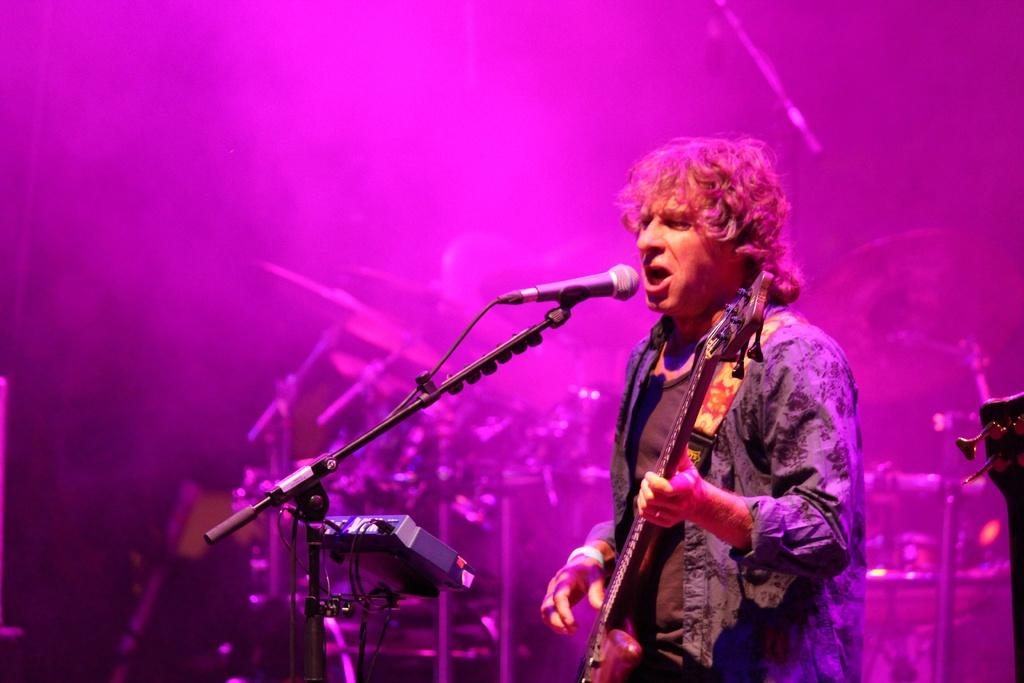What is the man in the image doing? The man is playing a guitar and singing. What objects in the image are related to music? The guitar and microphone are musical instruments in the image. What is the man holding in the image? The man is holding a guitar in the image. What type of trouble is the man having with the bears in the image? There are no bears present in the image, so the man is not having any trouble with them. How does the man sort the musical instruments in the image? The man is not sorting any musical instruments in the image; he is playing a guitar and singing. 